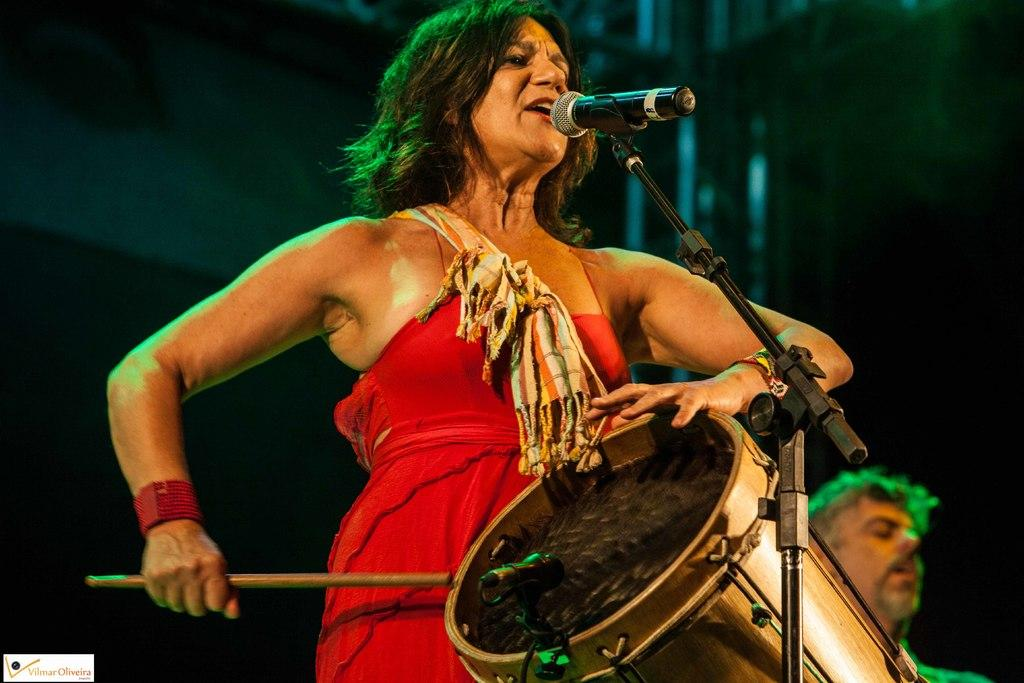What is the woman wearing in the image? The woman is wearing a red dress. What is the woman doing with the musical instrument in the image? The woman is playing a musical drum. What device is present for amplifying the woman's voice? There is a microphone with a holder in the image. What activity is the woman engaged in while using the microphone? The woman is singing in front of the microphone. Who is standing beside the woman in the image? There is a man standing beside the woman. What type of humor can be seen in the woman's facial expression in the image? There is no indication of humor or facial expression in the image; it only shows the woman playing a musical drum and singing. Can you tell me how many cattle are present in the image? There are no cattle present in the image. 